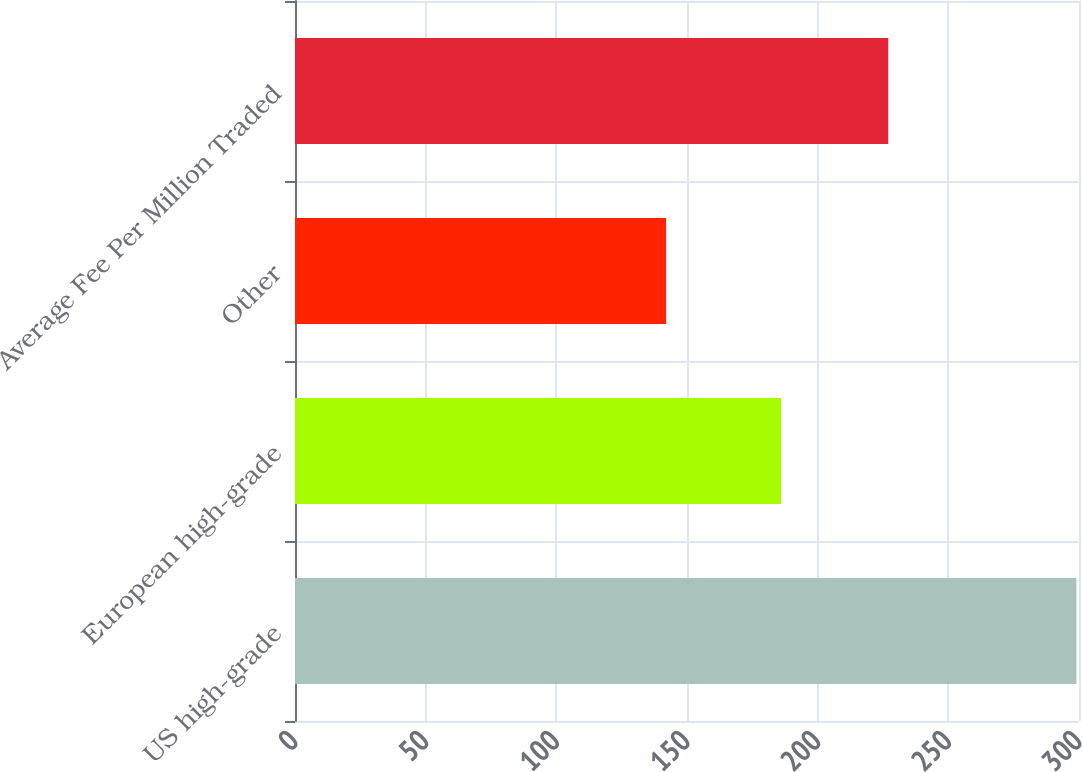Convert chart. <chart><loc_0><loc_0><loc_500><loc_500><bar_chart><fcel>US high-grade<fcel>European high-grade<fcel>Other<fcel>Average Fee Per Million Traded<nl><fcel>299<fcel>186<fcel>142<fcel>227<nl></chart> 